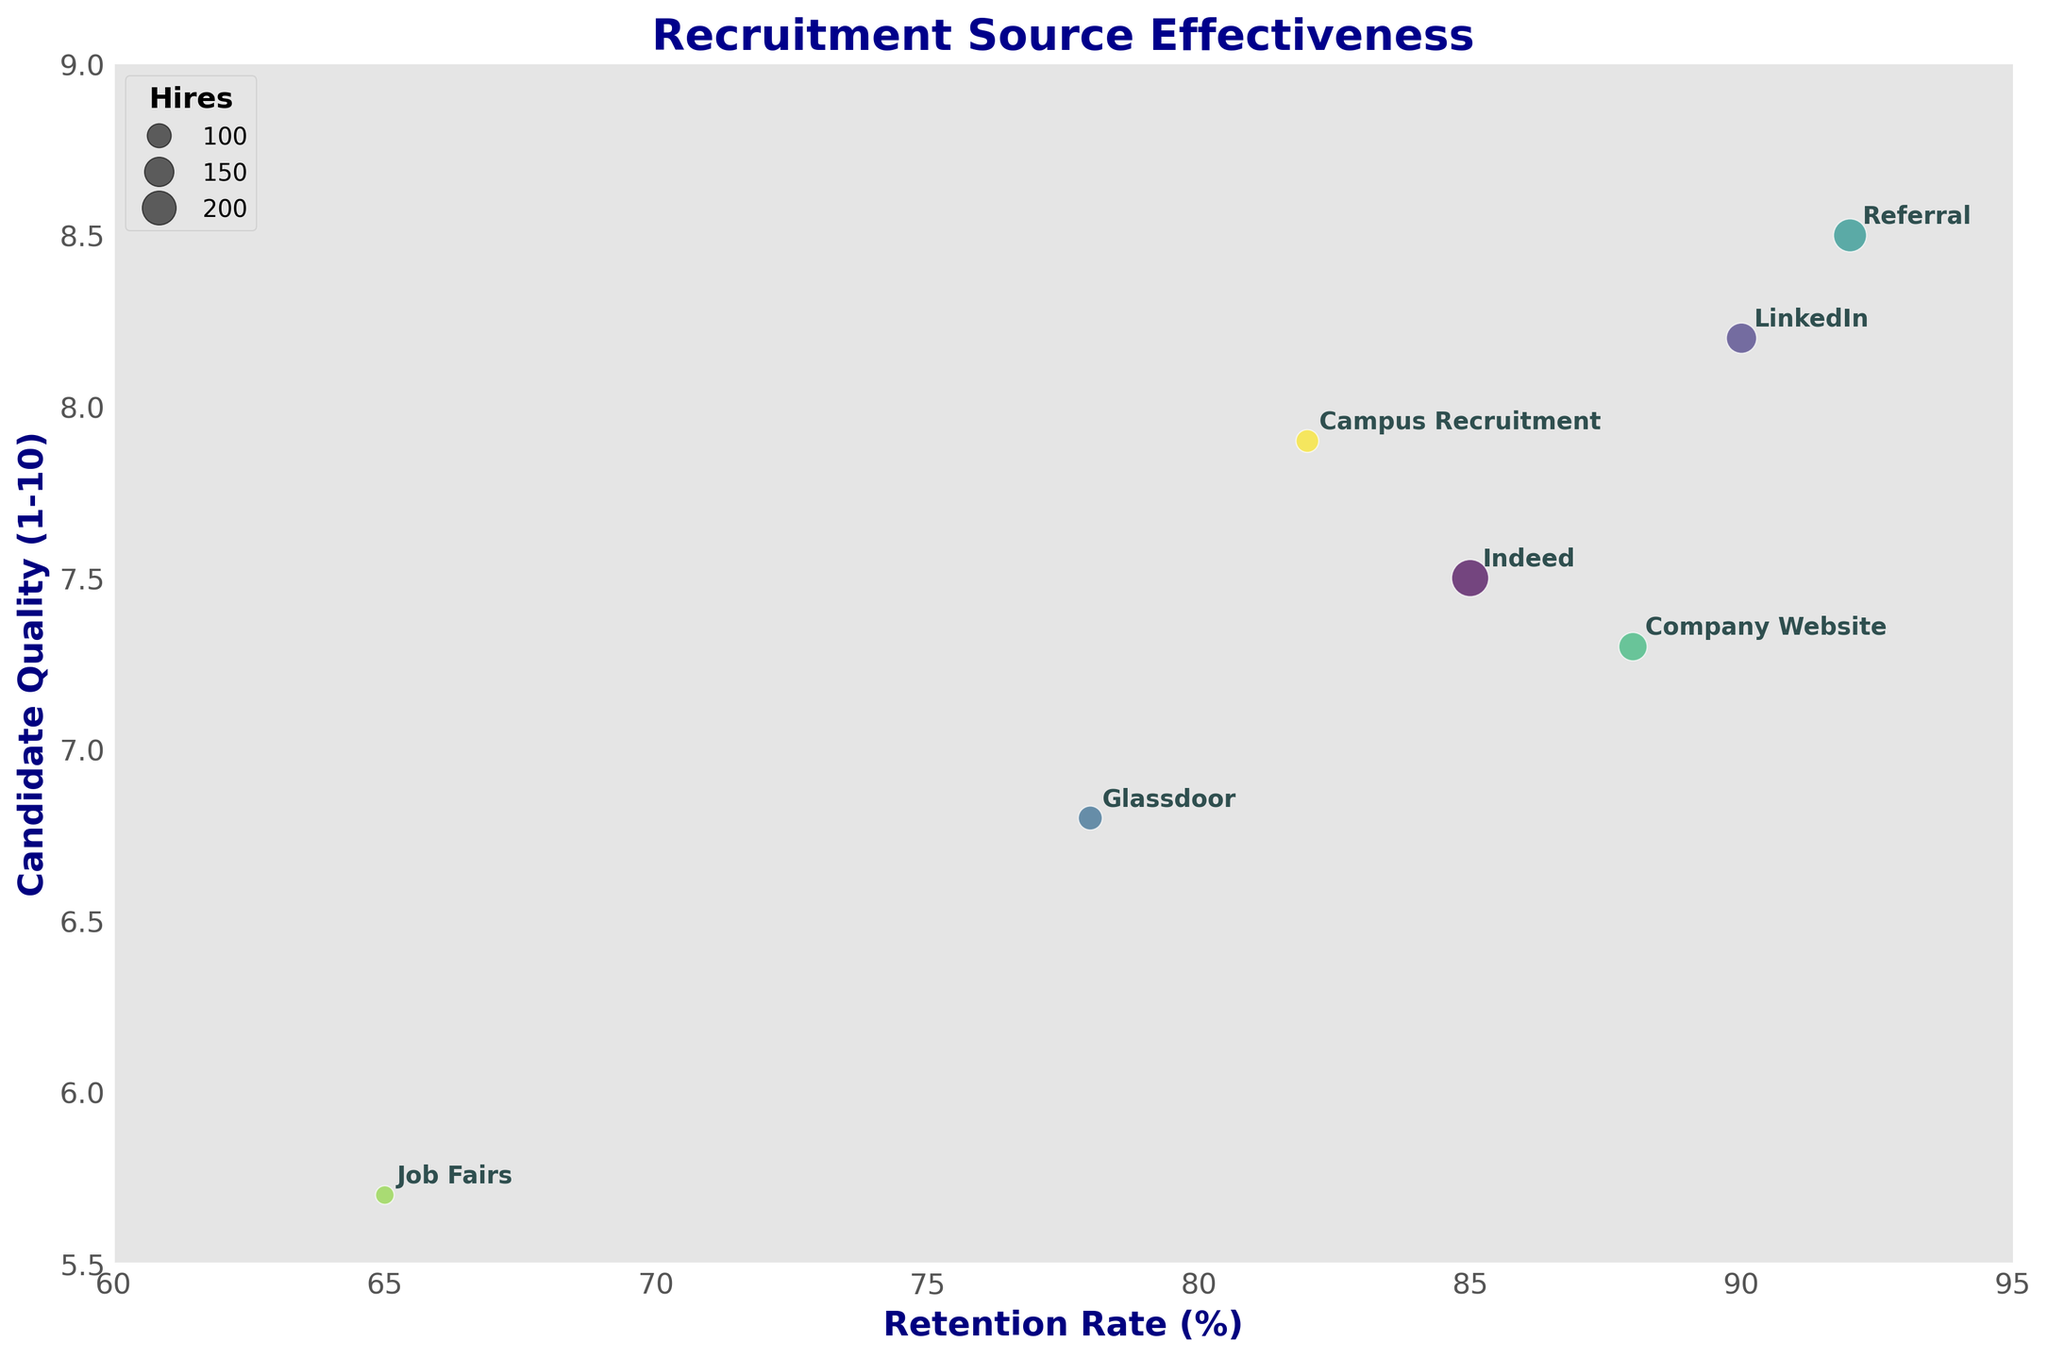How many recruitment sources are shown in the figure? Count the distinct recruitment sources labeled in the figure.
Answer: 7 What is the title of the figure? Read the title text at the top of the figure.
Answer: Recruitment Source Effectiveness Which recruitment source has the highest Candidate Quality? Look for the highest Y-axis value and read the corresponding label.
Answer: Referral Which source has the lowest Retention Rate and what is its value? Find the lowest X-axis value and read the corresponding label and value.
Answer: Job Fairs, 65% What is the average Candidate Quality of Indeed and Glassdoor? Find the Candidate Quality values for Indeed (7.5) and Glassdoor (6.8), then calculate the average: (7.5 + 6.8) / 2 = 7.15
Answer: 7.15 Which source has more Hires, LinkedIn or Campus Recruitment? Compare the bubble sizes of LinkedIn and Campus Recruitment and identify the larger one.
Answer: LinkedIn How many sources have a Retention Rate of 85% or higher? Count the sources with X-axis values greater than or equal to 85.
Answer: 5 What is the range of Candidate Quality values in the figure? Identify the highest (8.5) and lowest (5.7) Y-axis values and calculate the difference: 8.5 - 5.7 = 2.8
Answer: 2.8 Which recruitment source has the second highest Retention Rate, and what is its Candidate Quality? Sort recruitment sources by Retention Rate, identify the second highest (Company Website, 88), and find its Y-axis value.
Answer: Company Website, 7.3 Are there any recruitment sources with both Retention Rate above 90% and Candidate Quality above 8? If so, name them. Check the sources with X-axis values above 90 and Y-axis values above 8, then list those that meet both criteria.
Answer: Referral 